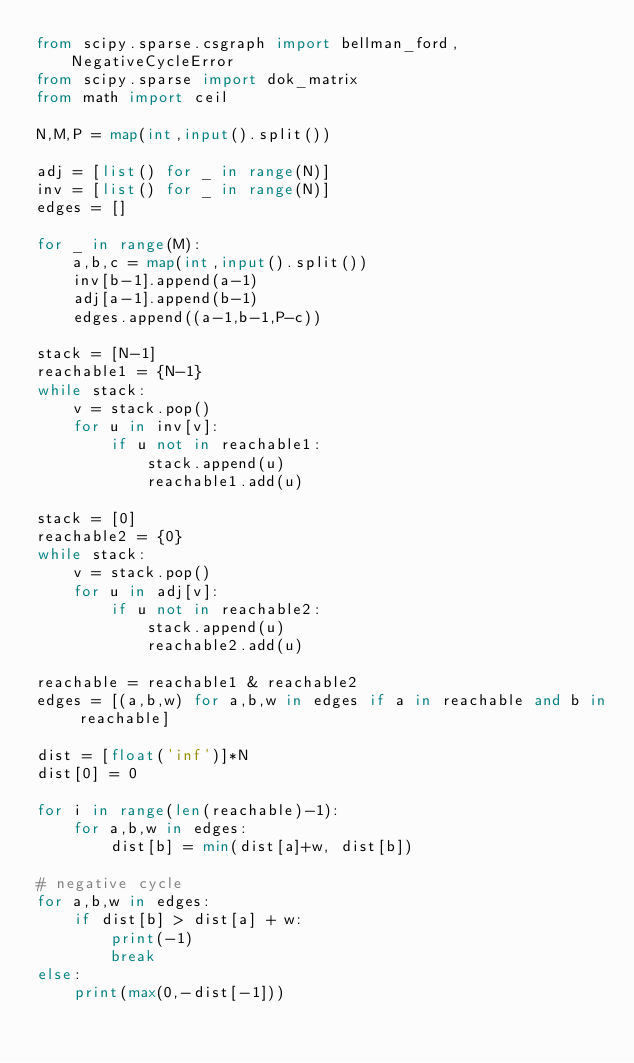<code> <loc_0><loc_0><loc_500><loc_500><_Python_>from scipy.sparse.csgraph import bellman_ford, NegativeCycleError
from scipy.sparse import dok_matrix
from math import ceil

N,M,P = map(int,input().split())

adj = [list() for _ in range(N)]
inv = [list() for _ in range(N)]
edges = []

for _ in range(M):
    a,b,c = map(int,input().split())
    inv[b-1].append(a-1)
    adj[a-1].append(b-1)
    edges.append((a-1,b-1,P-c))

stack = [N-1]
reachable1 = {N-1}
while stack:
    v = stack.pop()
    for u in inv[v]:
        if u not in reachable1:
            stack.append(u)
            reachable1.add(u)

stack = [0]
reachable2 = {0}
while stack:
    v = stack.pop()
    for u in adj[v]:
        if u not in reachable2:
            stack.append(u)
            reachable2.add(u)

reachable = reachable1 & reachable2
edges = [(a,b,w) for a,b,w in edges if a in reachable and b in reachable]

dist = [float('inf')]*N
dist[0] = 0

for i in range(len(reachable)-1):
    for a,b,w in edges:
        dist[b] = min(dist[a]+w, dist[b])

# negative cycle
for a,b,w in edges:
    if dist[b] > dist[a] + w:
        print(-1)
        break
else:
    print(max(0,-dist[-1]))</code> 